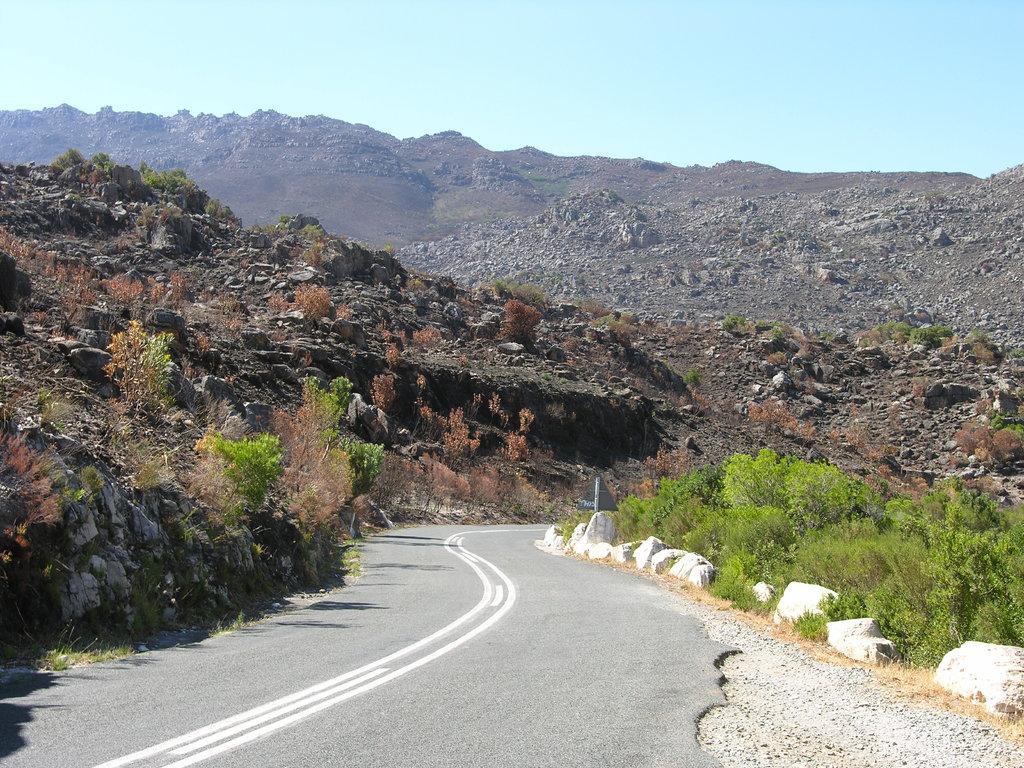Please provide a concise description of this image. In this image I see the road on which there are white lines and I see the rocks over here and I see few plants. In the background I see the mountains and the blue sky. 